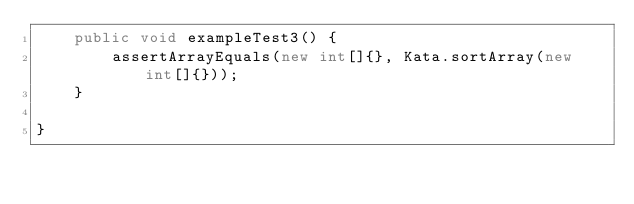Convert code to text. <code><loc_0><loc_0><loc_500><loc_500><_Java_>    public void exampleTest3() {
        assertArrayEquals(new int[]{}, Kata.sortArray(new int[]{}));
    }

}</code> 